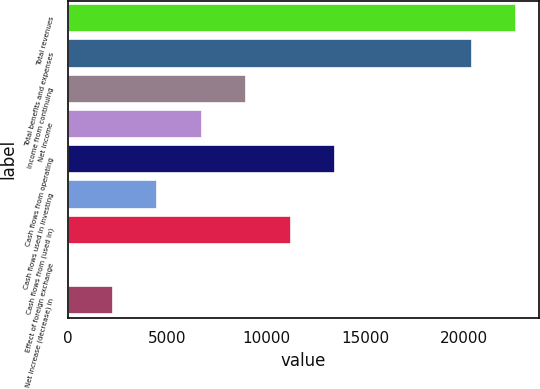Convert chart. <chart><loc_0><loc_0><loc_500><loc_500><bar_chart><fcel>Total revenues<fcel>Total benefits and expenses<fcel>Income from continuing<fcel>Net income<fcel>Cash flows from operating<fcel>Cash flows used in investing<fcel>Cash flows from (used in)<fcel>Effect of foreign exchange<fcel>Net increase (decrease) in<nl><fcel>22628<fcel>20379<fcel>8998<fcel>6749<fcel>13496<fcel>4500<fcel>11247<fcel>2<fcel>2251<nl></chart> 